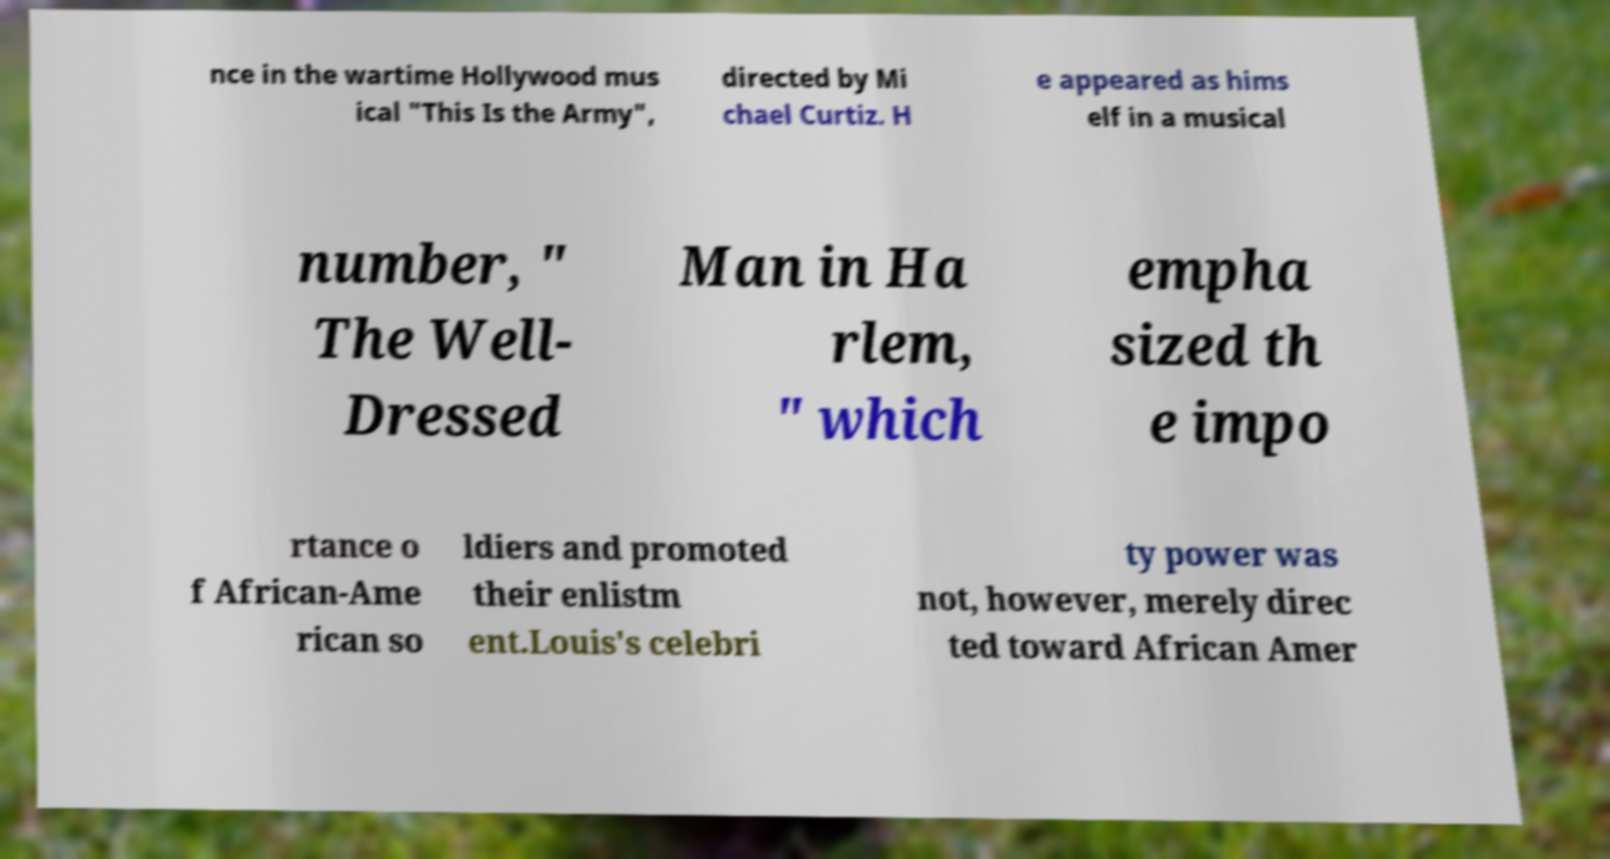What messages or text are displayed in this image? I need them in a readable, typed format. nce in the wartime Hollywood mus ical "This Is the Army", directed by Mi chael Curtiz. H e appeared as hims elf in a musical number, " The Well- Dressed Man in Ha rlem, " which empha sized th e impo rtance o f African-Ame rican so ldiers and promoted their enlistm ent.Louis's celebri ty power was not, however, merely direc ted toward African Amer 